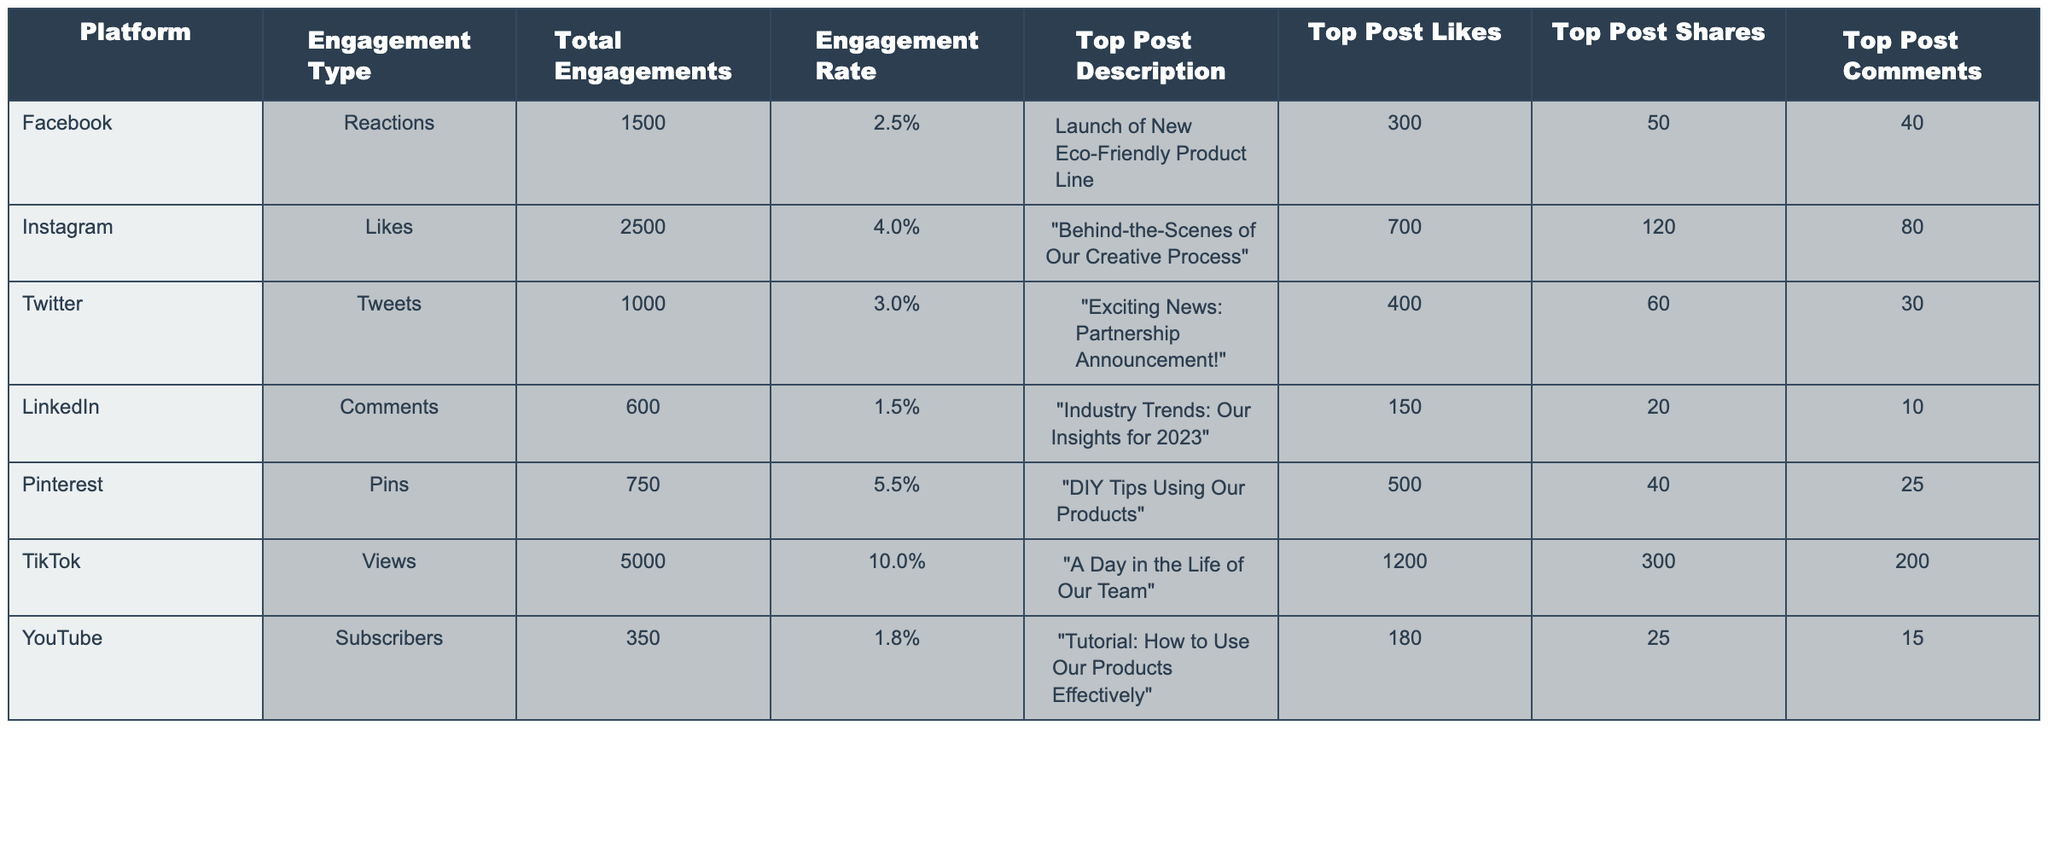What platform had the highest total engagements? By comparing the "Total Engagements" column, TikTok has the highest total engagements at 5000, surpassing all other platforms significantly.
Answer: TikTok What is the engagement rate for Instagram? The engagement rate for Instagram is explicitly stated in the table as 4.0%.
Answer: 4.0% Which platform received the highest likes on its top post? In the "Top Post Likes" column, Instagram's top post received 700 likes, which is the highest compared to other platforms.
Answer: Instagram What is the average total engagements across all platforms? To find the average, add all the total engagements: 1500 + 2500 + 1000 + 600 + 750 + 5000 + 350 = 10000. Then, divide by the number of platforms (7): 10000/7 = approximately 1428.57.
Answer: Approximately 1428.57 Did Pinterest have more total engagements than Facebook? Comparing the "Total Engagements," Pinterest has 750 engagements, which is less than Facebook's 1500 engagements. Thus, the statement is false.
Answer: No Which platform had the highest engagement rate? By reviewing the "Engagement Rate" column, TikTok has the highest engagement rate at 10.0%, compared to others.
Answer: TikTok What is the total number of comments received on the top post across all platforms? Summing the "Top Post Comments": 40 (Facebook) + 80 (Instagram) + 30 (Twitter) + 10 (LinkedIn) + 25 (Pinterest) + 200 (TikTok) + 15 (YouTube) gives a total of 400 comments.
Answer: 400 Which two platforms had the closest engagement rates? By analyzing the engagement rates, LinkedIn at 1.5% and YouTube at 1.8% are the closest among all platforms, differing by 0.3%.
Answer: LinkedIn and YouTube What was the top post description on TikTok? The "Top Post Description" for TikTok is "A Day in the Life of Our Team" as listed in the table.
Answer: A Day in the Life of Our Team Is the total number of shares for Instagram's top post greater than the total likes for Facebook's top post? Instagram's top post shares are 120, and Facebook's top post likes are 300. Since 120 is less than 300, the statement is false.
Answer: No 